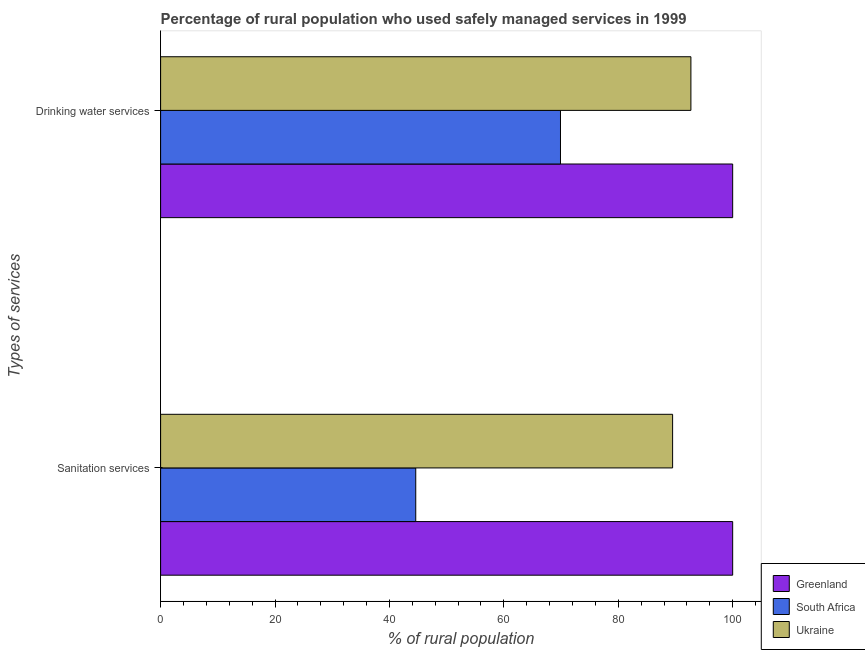How many different coloured bars are there?
Provide a short and direct response. 3. How many groups of bars are there?
Provide a short and direct response. 2. Are the number of bars per tick equal to the number of legend labels?
Your answer should be very brief. Yes. Are the number of bars on each tick of the Y-axis equal?
Offer a terse response. Yes. How many bars are there on the 2nd tick from the top?
Provide a short and direct response. 3. How many bars are there on the 2nd tick from the bottom?
Make the answer very short. 3. What is the label of the 1st group of bars from the top?
Offer a very short reply. Drinking water services. What is the percentage of rural population who used sanitation services in Ukraine?
Provide a succinct answer. 89.5. Across all countries, what is the minimum percentage of rural population who used drinking water services?
Offer a very short reply. 69.9. In which country was the percentage of rural population who used sanitation services maximum?
Make the answer very short. Greenland. In which country was the percentage of rural population who used drinking water services minimum?
Your answer should be very brief. South Africa. What is the total percentage of rural population who used drinking water services in the graph?
Your answer should be compact. 262.6. What is the difference between the percentage of rural population who used drinking water services in Greenland and that in Ukraine?
Keep it short and to the point. 7.3. What is the difference between the percentage of rural population who used drinking water services in South Africa and the percentage of rural population who used sanitation services in Ukraine?
Keep it short and to the point. -19.6. What is the average percentage of rural population who used sanitation services per country?
Make the answer very short. 78.03. What is the ratio of the percentage of rural population who used drinking water services in Ukraine to that in Greenland?
Make the answer very short. 0.93. In how many countries, is the percentage of rural population who used sanitation services greater than the average percentage of rural population who used sanitation services taken over all countries?
Ensure brevity in your answer.  2. What does the 2nd bar from the top in Drinking water services represents?
Ensure brevity in your answer.  South Africa. What does the 1st bar from the bottom in Drinking water services represents?
Offer a very short reply. Greenland. How many bars are there?
Ensure brevity in your answer.  6. How many countries are there in the graph?
Your response must be concise. 3. What is the difference between two consecutive major ticks on the X-axis?
Provide a short and direct response. 20. Are the values on the major ticks of X-axis written in scientific E-notation?
Your answer should be very brief. No. Does the graph contain any zero values?
Keep it short and to the point. No. Where does the legend appear in the graph?
Provide a short and direct response. Bottom right. What is the title of the graph?
Your response must be concise. Percentage of rural population who used safely managed services in 1999. Does "New Caledonia" appear as one of the legend labels in the graph?
Provide a short and direct response. No. What is the label or title of the X-axis?
Your answer should be very brief. % of rural population. What is the label or title of the Y-axis?
Give a very brief answer. Types of services. What is the % of rural population of South Africa in Sanitation services?
Give a very brief answer. 44.6. What is the % of rural population of Ukraine in Sanitation services?
Offer a very short reply. 89.5. What is the % of rural population of Greenland in Drinking water services?
Your response must be concise. 100. What is the % of rural population of South Africa in Drinking water services?
Provide a succinct answer. 69.9. What is the % of rural population in Ukraine in Drinking water services?
Offer a terse response. 92.7. Across all Types of services, what is the maximum % of rural population in South Africa?
Offer a very short reply. 69.9. Across all Types of services, what is the maximum % of rural population in Ukraine?
Give a very brief answer. 92.7. Across all Types of services, what is the minimum % of rural population of Greenland?
Your answer should be compact. 100. Across all Types of services, what is the minimum % of rural population in South Africa?
Your response must be concise. 44.6. Across all Types of services, what is the minimum % of rural population in Ukraine?
Keep it short and to the point. 89.5. What is the total % of rural population of South Africa in the graph?
Your answer should be very brief. 114.5. What is the total % of rural population of Ukraine in the graph?
Your answer should be compact. 182.2. What is the difference between the % of rural population of Greenland in Sanitation services and that in Drinking water services?
Provide a short and direct response. 0. What is the difference between the % of rural population in South Africa in Sanitation services and that in Drinking water services?
Offer a very short reply. -25.3. What is the difference between the % of rural population in Greenland in Sanitation services and the % of rural population in South Africa in Drinking water services?
Make the answer very short. 30.1. What is the difference between the % of rural population of Greenland in Sanitation services and the % of rural population of Ukraine in Drinking water services?
Your response must be concise. 7.3. What is the difference between the % of rural population of South Africa in Sanitation services and the % of rural population of Ukraine in Drinking water services?
Give a very brief answer. -48.1. What is the average % of rural population in Greenland per Types of services?
Give a very brief answer. 100. What is the average % of rural population of South Africa per Types of services?
Offer a very short reply. 57.25. What is the average % of rural population in Ukraine per Types of services?
Provide a succinct answer. 91.1. What is the difference between the % of rural population in Greenland and % of rural population in South Africa in Sanitation services?
Give a very brief answer. 55.4. What is the difference between the % of rural population of South Africa and % of rural population of Ukraine in Sanitation services?
Give a very brief answer. -44.9. What is the difference between the % of rural population of Greenland and % of rural population of South Africa in Drinking water services?
Your answer should be compact. 30.1. What is the difference between the % of rural population in Greenland and % of rural population in Ukraine in Drinking water services?
Provide a short and direct response. 7.3. What is the difference between the % of rural population of South Africa and % of rural population of Ukraine in Drinking water services?
Provide a short and direct response. -22.8. What is the ratio of the % of rural population of South Africa in Sanitation services to that in Drinking water services?
Offer a very short reply. 0.64. What is the ratio of the % of rural population of Ukraine in Sanitation services to that in Drinking water services?
Offer a terse response. 0.97. What is the difference between the highest and the second highest % of rural population of South Africa?
Ensure brevity in your answer.  25.3. What is the difference between the highest and the second highest % of rural population of Ukraine?
Make the answer very short. 3.2. What is the difference between the highest and the lowest % of rural population of Greenland?
Keep it short and to the point. 0. What is the difference between the highest and the lowest % of rural population in South Africa?
Ensure brevity in your answer.  25.3. What is the difference between the highest and the lowest % of rural population in Ukraine?
Provide a succinct answer. 3.2. 